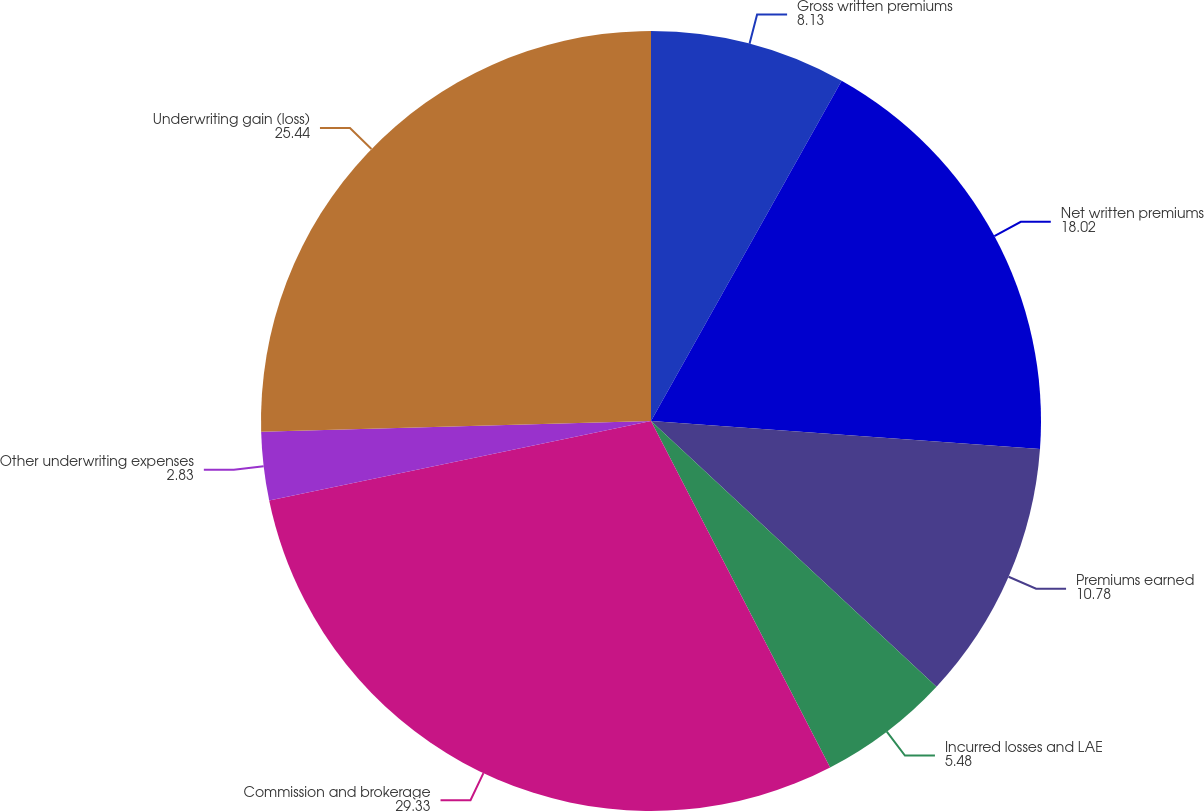Convert chart to OTSL. <chart><loc_0><loc_0><loc_500><loc_500><pie_chart><fcel>Gross written premiums<fcel>Net written premiums<fcel>Premiums earned<fcel>Incurred losses and LAE<fcel>Commission and brokerage<fcel>Other underwriting expenses<fcel>Underwriting gain (loss)<nl><fcel>8.13%<fcel>18.02%<fcel>10.78%<fcel>5.48%<fcel>29.33%<fcel>2.83%<fcel>25.44%<nl></chart> 